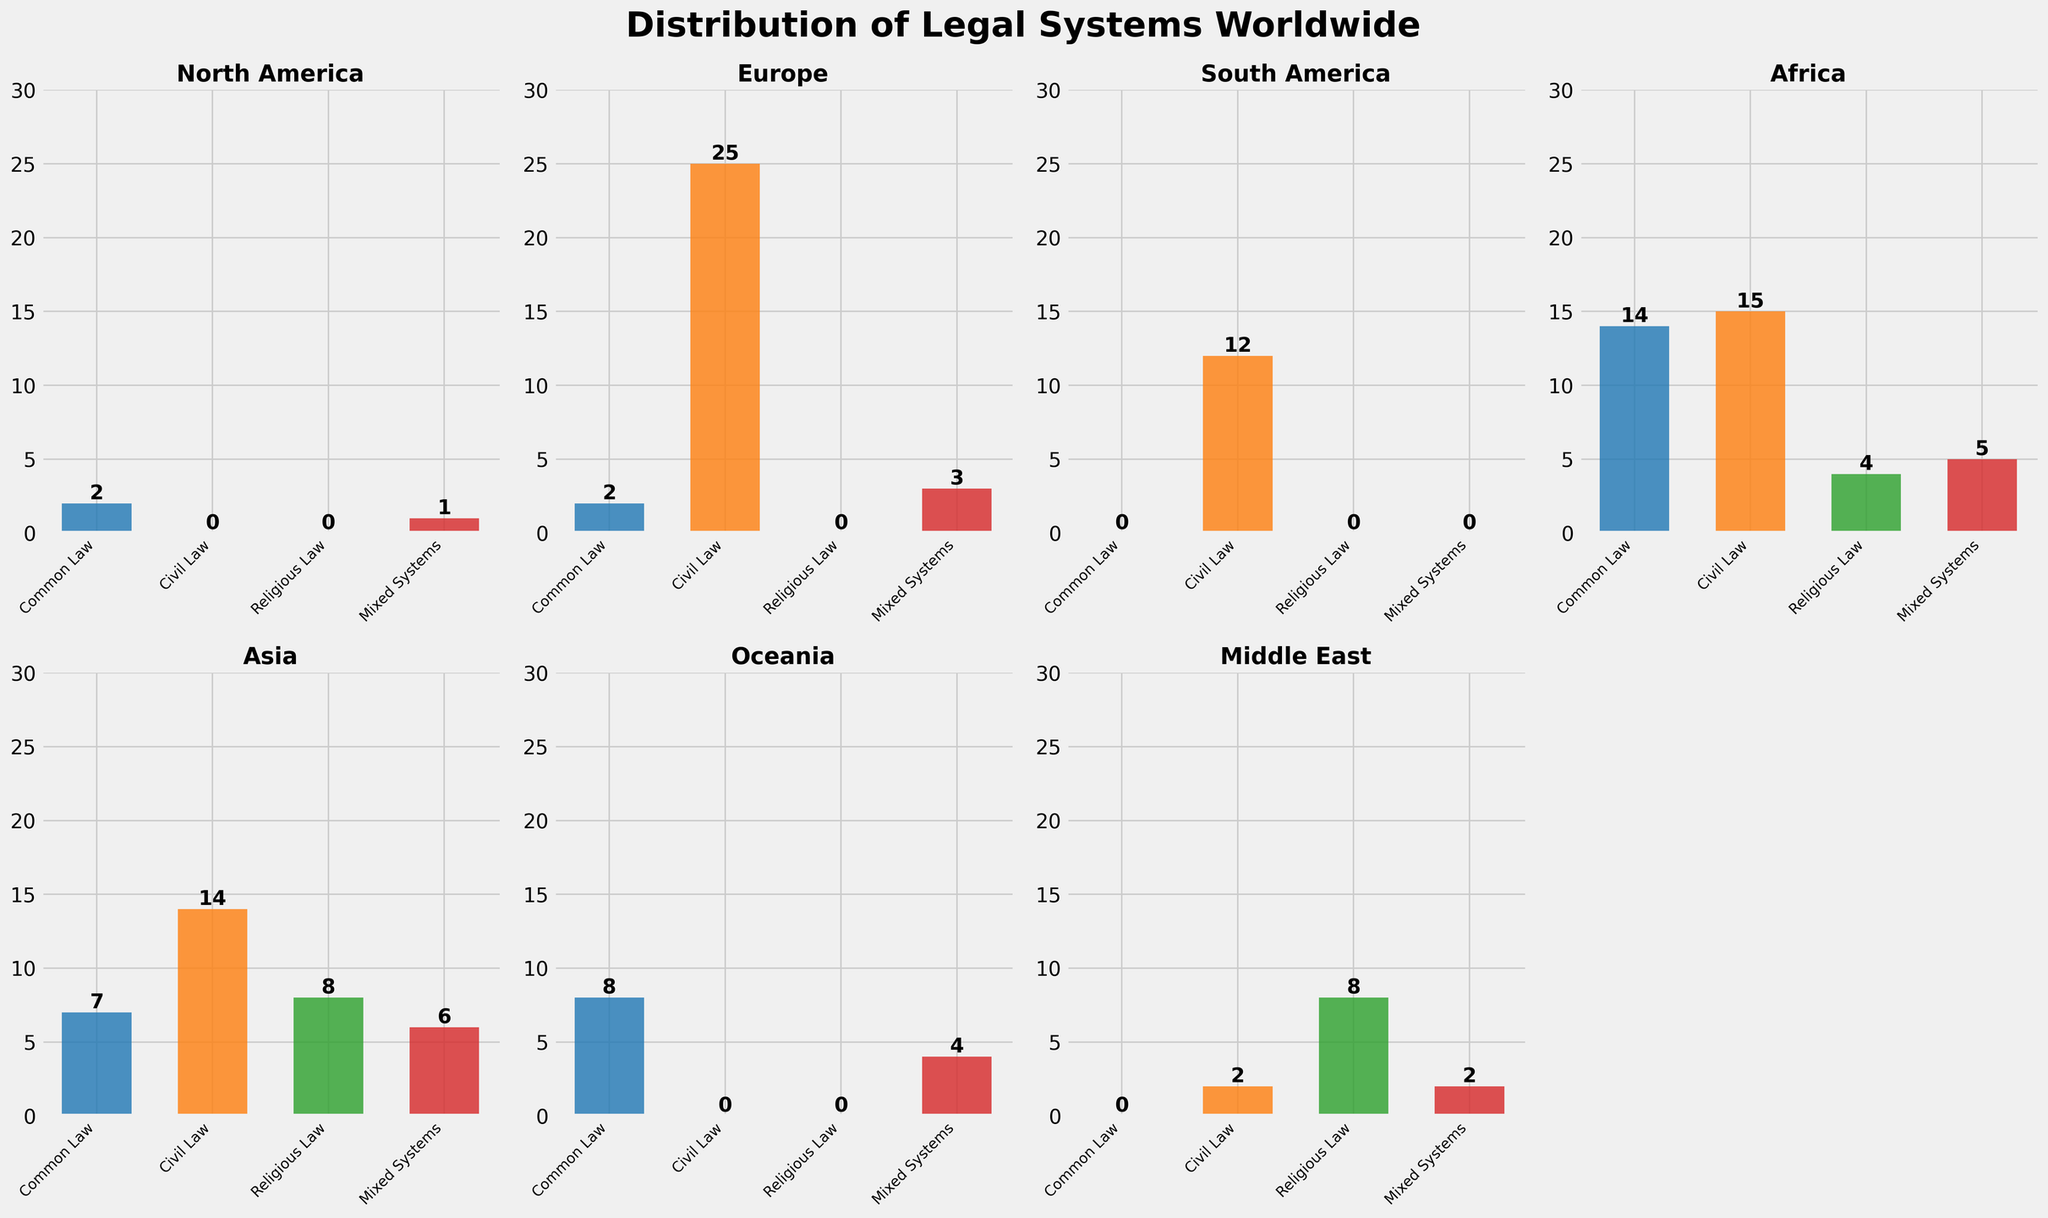Which region has the most countries with mixed legal systems? The bar charts show the number of countries with different legal systems for each region. By comparing the height of the bars, we observe that Africa and Oceania have the tallest bars for mixed systems. Given the numerical values, Africa has five while Oceania has four. Therefore, Africa has the most mixed systems.
Answer: Africa How many regions have at least one country with a common law system? To determine this, count the number of regions with a non-zero bar height for the common law category. North America, Europe, Africa, Asia, and Oceania all have at least one country with a common law system, totaling five regions.
Answer: Five Which region has the highest number of countries with civil law systems? By observing the height of the bars in the civil law category, Europe has the tallest bar with 25 countries, indicating it has the highest number in this legal system category.
Answer: Europe What's the combined number of countries with religious law in Africa and the Middle East? From the bar charts, Africa has four countries with religious law, and the Middle East has eight. Summing these values gives us 4 + 8 = 12.
Answer: 12 How does the number of countries with civil law in Asia compare to those in South America? The height of the civil law bar for Asia shows 14 countries, while South America's bar shows 12. Asia has two more countries with civil law than South America.
Answer: 2 more in Asia In which region is the proportion of countries with common law systems the highest? To find the highest proportion, divide the number of common law countries by the total for each region. Calculate the proportions: North America (2/3), Europe (2/30), Asia (7/35), Africa (14/38), Oceania (8/12). North America has the highest proportion as 2/3 > 7/12 > 8/22 > 14/38 > 2/30.
Answer: North America Which regions do not have any countries with religious law systems? By verifying which bar charts have a height of zero for religious law, North America, Europe, South America, and Oceania regions have no countries with religious law systems.
Answer: North America, Europe, South America, Oceania What is the average number of countries with civil law systems across all regions? Sum the number of countries with civil law across all regions and divide by the number of regions. Sum = 0 + 25 + 12 + 15 + 14 + 0 + 2 = 68; average = 68 / 7 = 9.71.
Answer: 9.71 